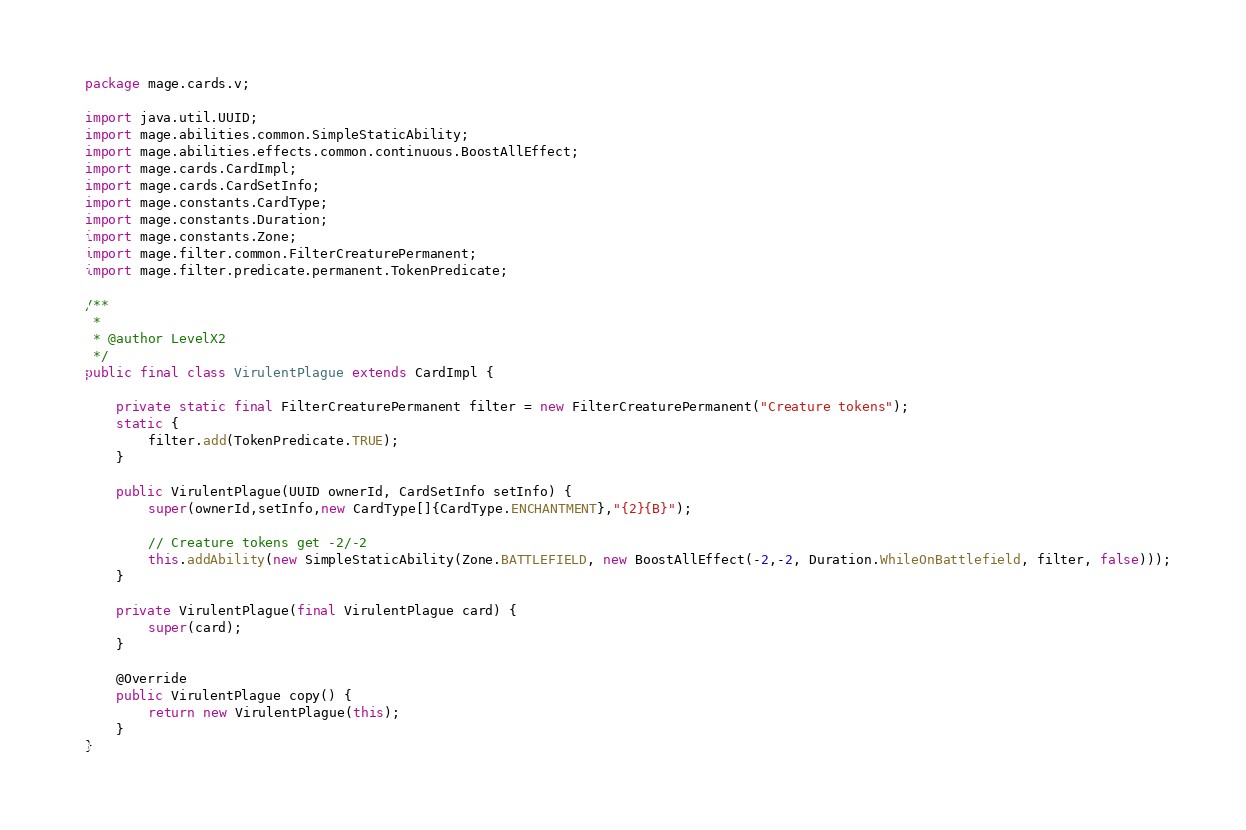<code> <loc_0><loc_0><loc_500><loc_500><_Java_>
package mage.cards.v;

import java.util.UUID;
import mage.abilities.common.SimpleStaticAbility;
import mage.abilities.effects.common.continuous.BoostAllEffect;
import mage.cards.CardImpl;
import mage.cards.CardSetInfo;
import mage.constants.CardType;
import mage.constants.Duration;
import mage.constants.Zone;
import mage.filter.common.FilterCreaturePermanent;
import mage.filter.predicate.permanent.TokenPredicate;

/**
 *
 * @author LevelX2
 */
public final class VirulentPlague extends CardImpl {

    private static final FilterCreaturePermanent filter = new FilterCreaturePermanent("Creature tokens");
    static {
        filter.add(TokenPredicate.TRUE);
    }

    public VirulentPlague(UUID ownerId, CardSetInfo setInfo) {
        super(ownerId,setInfo,new CardType[]{CardType.ENCHANTMENT},"{2}{B}");

        // Creature tokens get -2/-2
        this.addAbility(new SimpleStaticAbility(Zone.BATTLEFIELD, new BoostAllEffect(-2,-2, Duration.WhileOnBattlefield, filter, false)));
    }

    private VirulentPlague(final VirulentPlague card) {
        super(card);
    }

    @Override
    public VirulentPlague copy() {
        return new VirulentPlague(this);
    }
}
</code> 